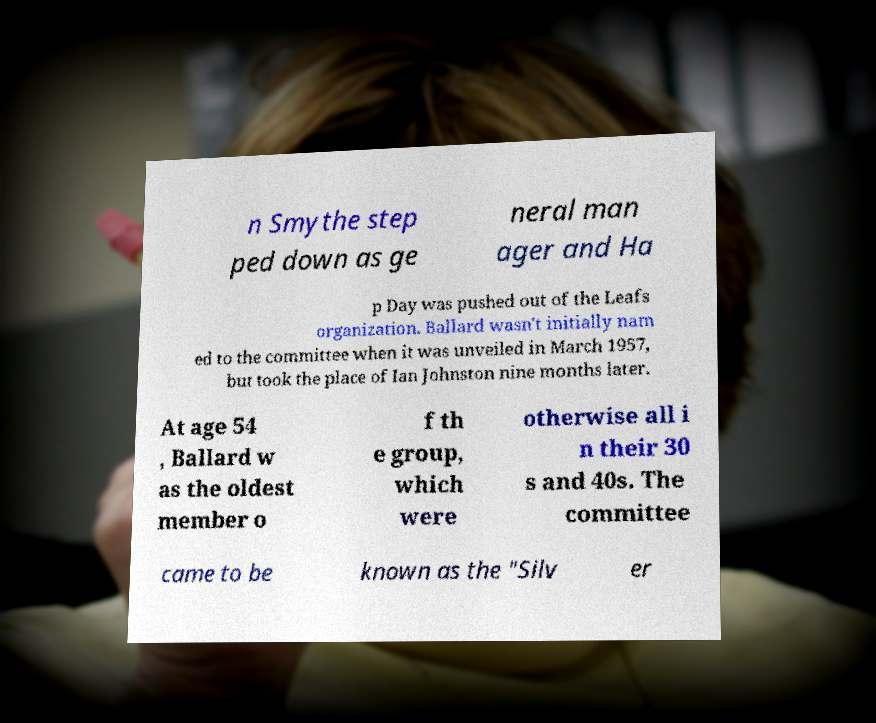Please identify and transcribe the text found in this image. n Smythe step ped down as ge neral man ager and Ha p Day was pushed out of the Leafs organization. Ballard wasn't initially nam ed to the committee when it was unveiled in March 1957, but took the place of Ian Johnston nine months later. At age 54 , Ballard w as the oldest member o f th e group, which were otherwise all i n their 30 s and 40s. The committee came to be known as the "Silv er 